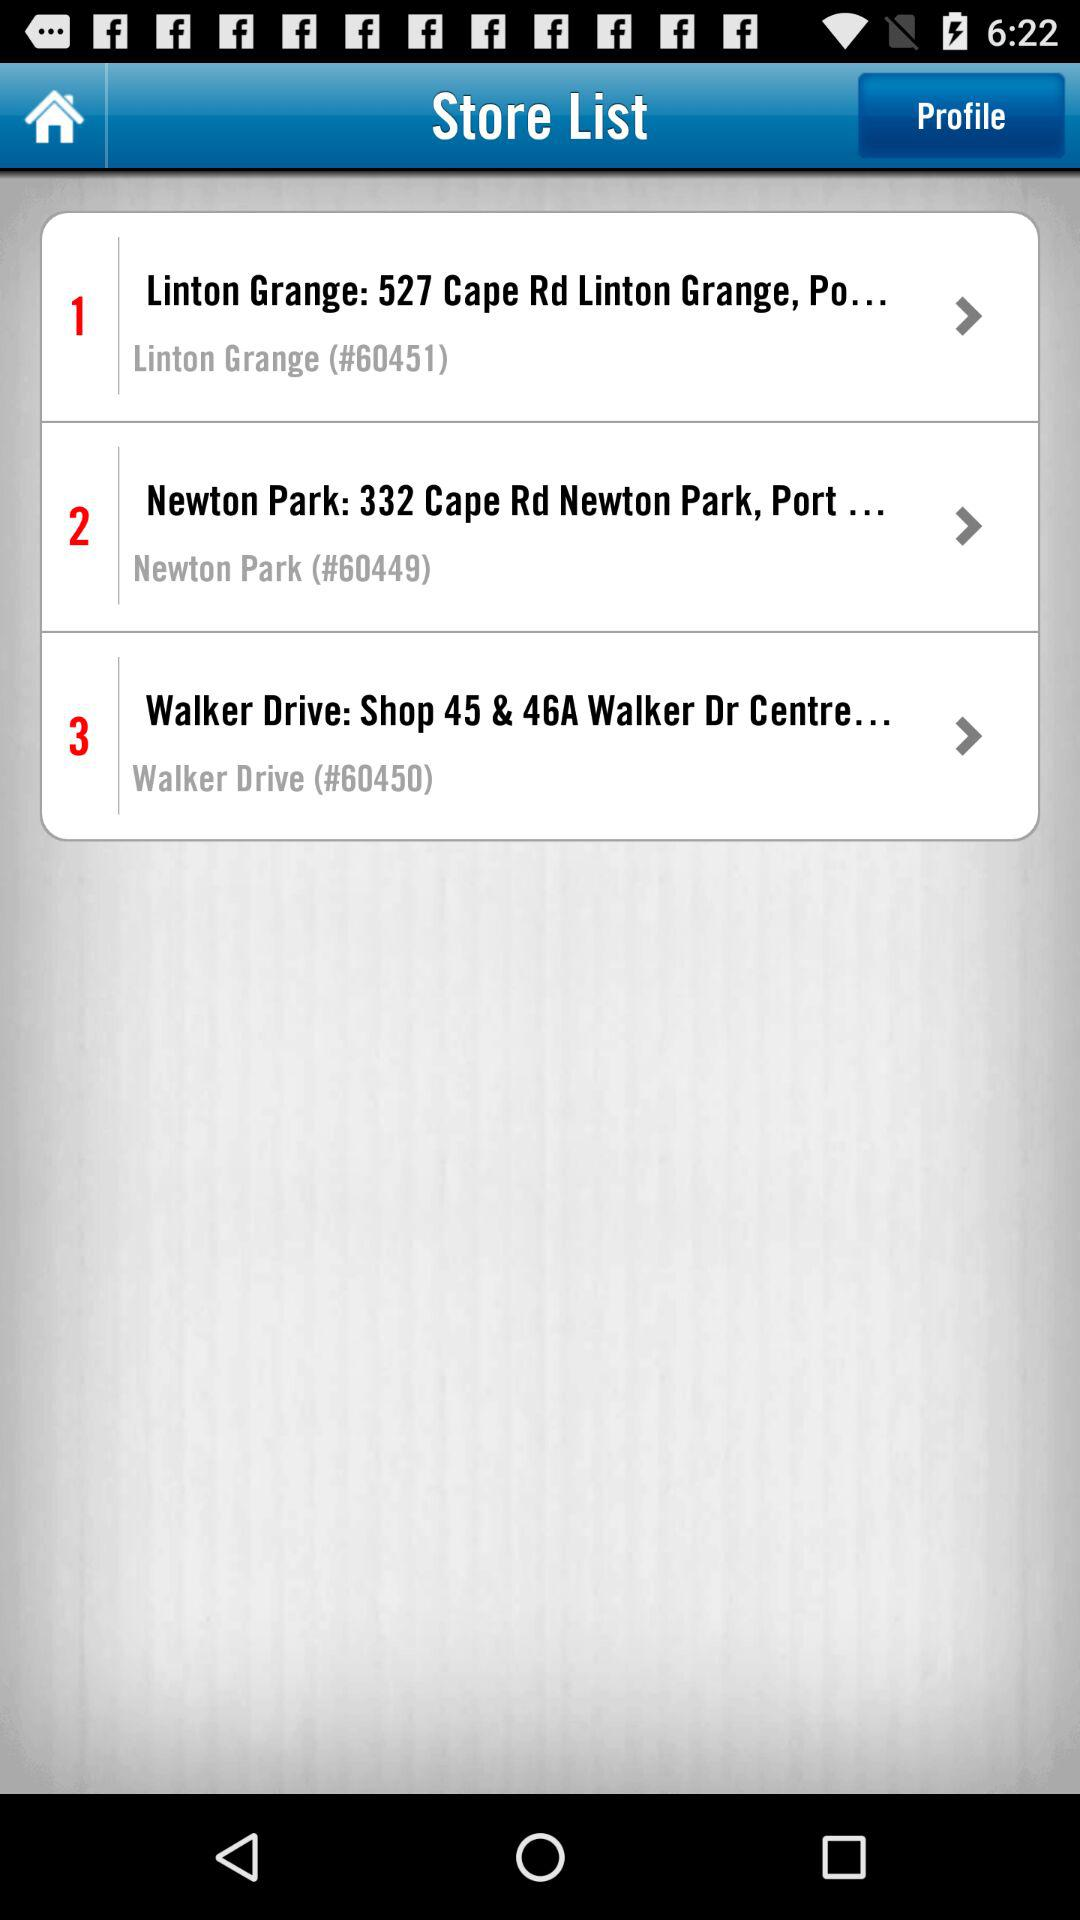What's the store number of Walker Drive in the store list? The store number of Walker Drive in the store list is #60450. 